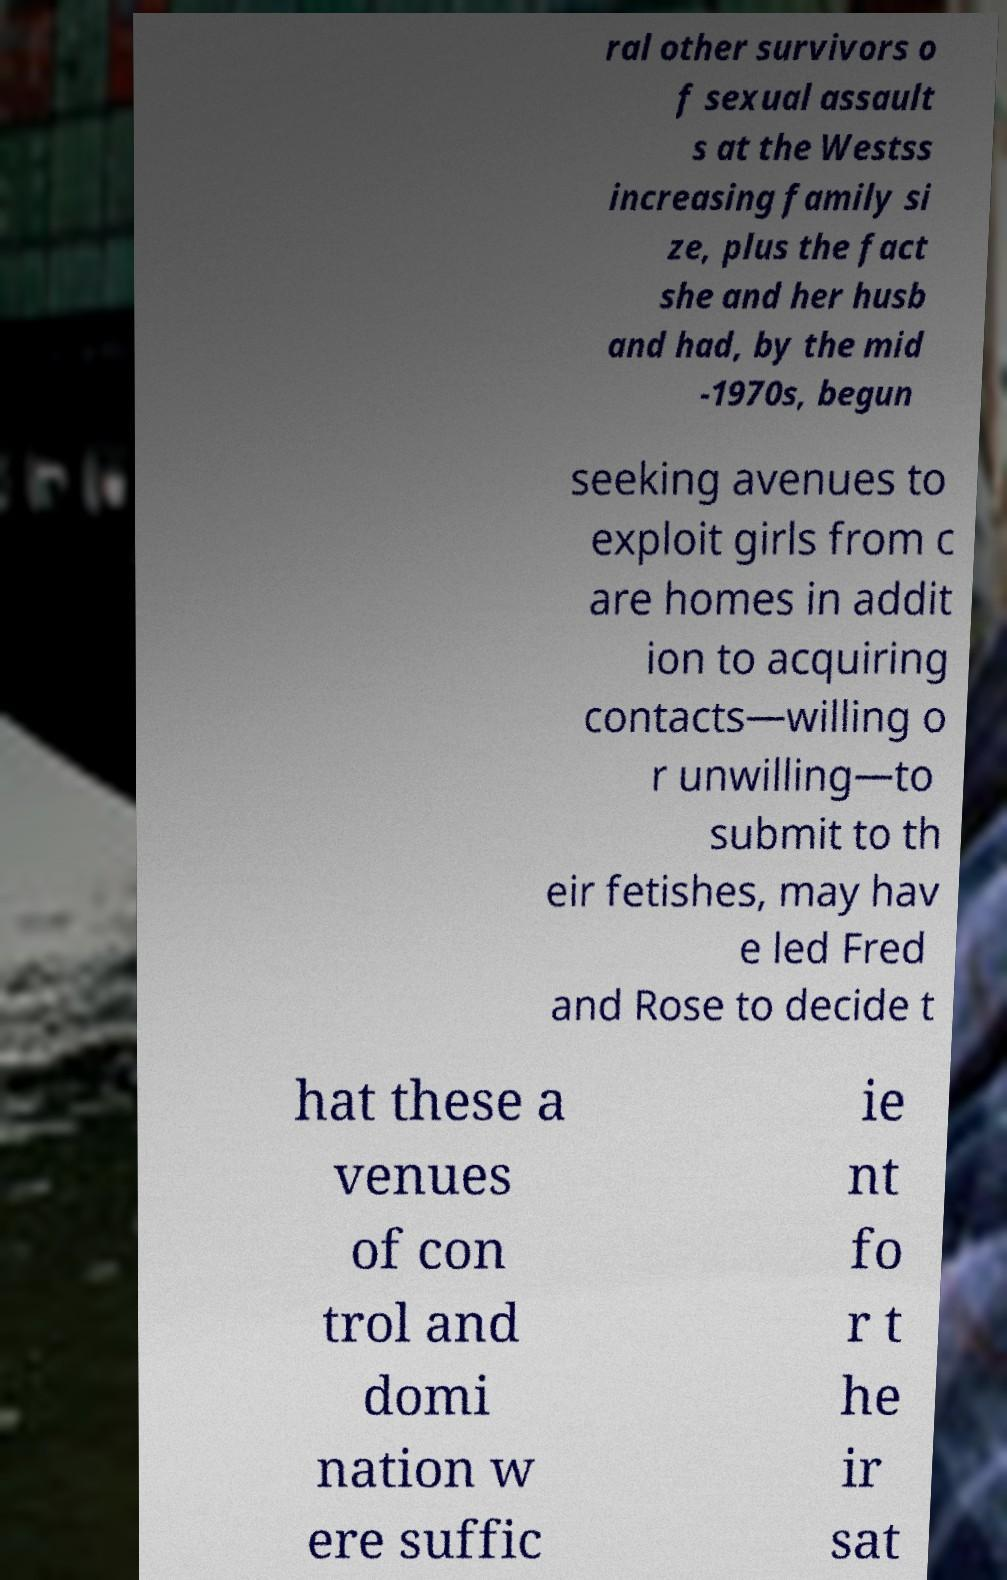I need the written content from this picture converted into text. Can you do that? ral other survivors o f sexual assault s at the Westss increasing family si ze, plus the fact she and her husb and had, by the mid -1970s, begun seeking avenues to exploit girls from c are homes in addit ion to acquiring contacts—willing o r unwilling—to submit to th eir fetishes, may hav e led Fred and Rose to decide t hat these a venues of con trol and domi nation w ere suffic ie nt fo r t he ir sat 